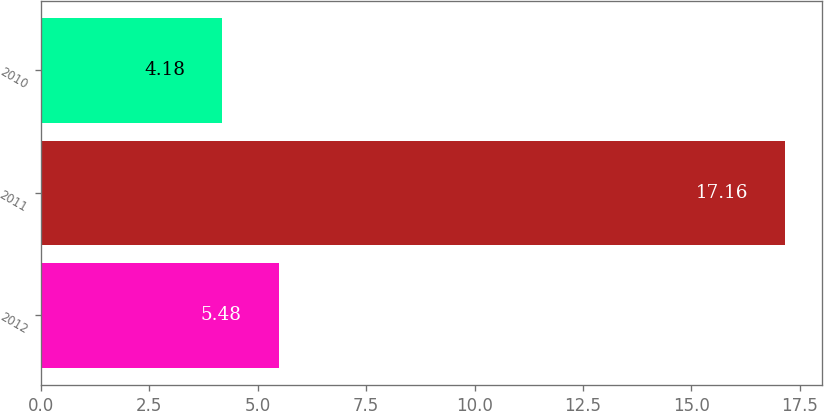<chart> <loc_0><loc_0><loc_500><loc_500><bar_chart><fcel>2012<fcel>2011<fcel>2010<nl><fcel>5.48<fcel>17.16<fcel>4.18<nl></chart> 